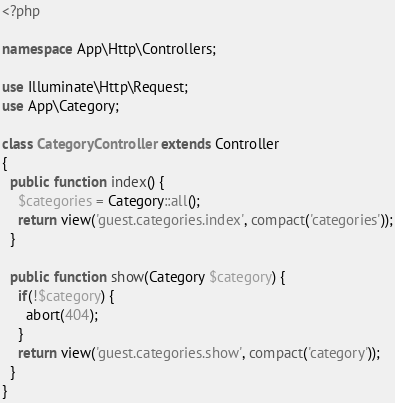Convert code to text. <code><loc_0><loc_0><loc_500><loc_500><_PHP_><?php

namespace App\Http\Controllers;

use Illuminate\Http\Request;
use App\Category;

class CategoryController extends Controller
{
  public function index() {
    $categories = Category::all();
    return view('guest.categories.index', compact('categories'));
  }

  public function show(Category $category) {
    if(!$category) {
      abort(404);
    }
    return view('guest.categories.show', compact('category'));
  }
}
</code> 